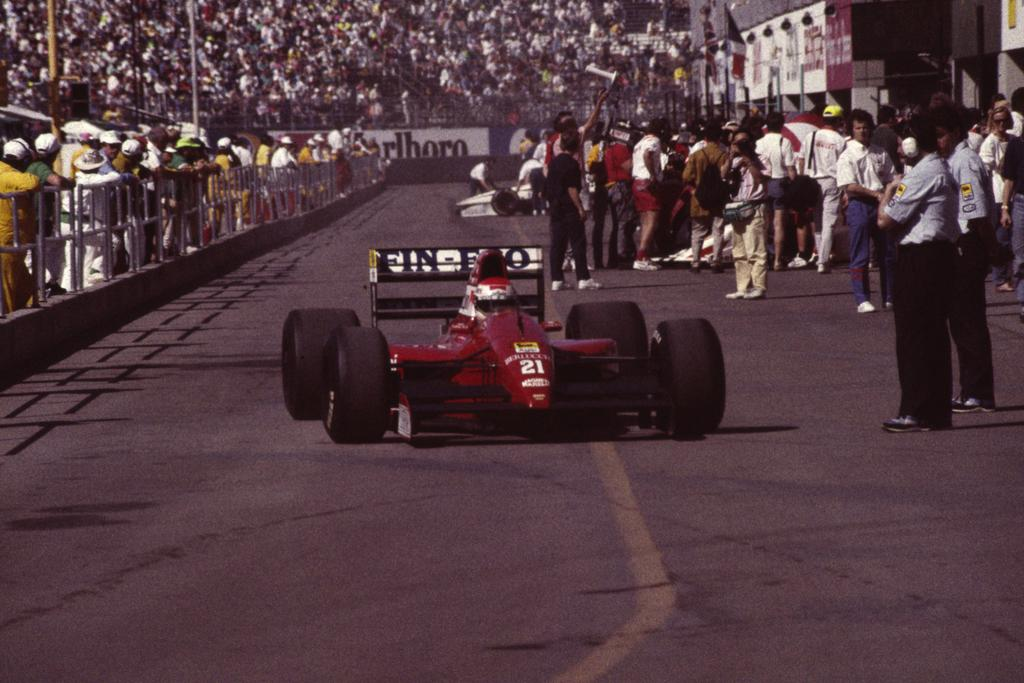What types of objects are present in the image? There are vehicles and people in the image. What can be seen surrounding the vehicles and people? There is fencing and a road in the image. What is the appearance of the road? The road has a yellow line. Where are the cherries being served in the image? There are no cherries present in the image. What is the source of the surprise in the image? There is no surprise or any indication of surprise in the image. 